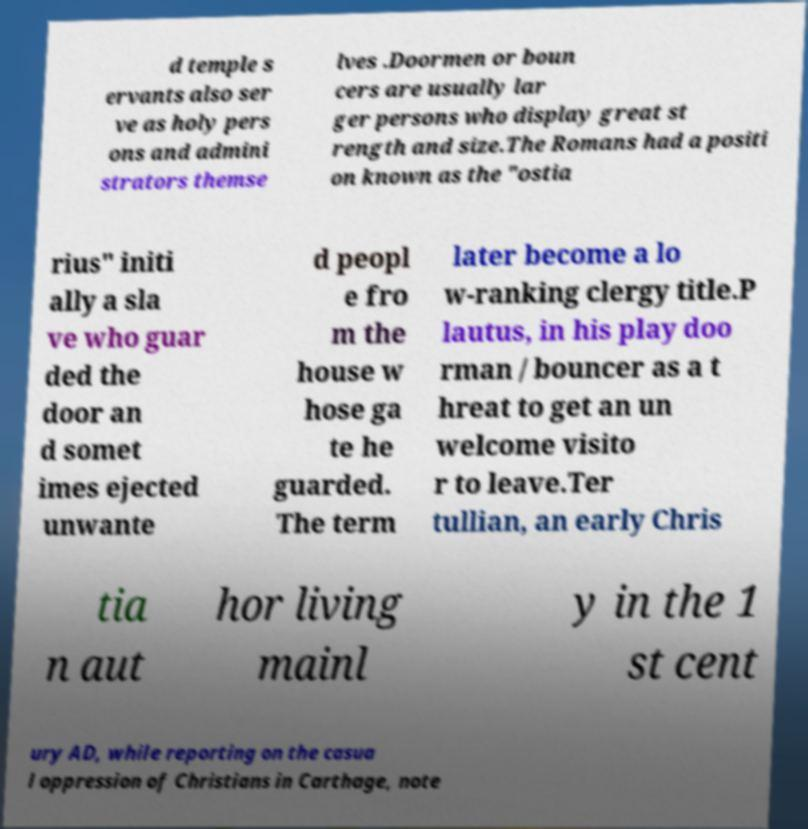There's text embedded in this image that I need extracted. Can you transcribe it verbatim? d temple s ervants also ser ve as holy pers ons and admini strators themse lves .Doormen or boun cers are usually lar ger persons who display great st rength and size.The Romans had a positi on known as the "ostia rius" initi ally a sla ve who guar ded the door an d somet imes ejected unwante d peopl e fro m the house w hose ga te he guarded. The term later become a lo w-ranking clergy title.P lautus, in his play doo rman / bouncer as a t hreat to get an un welcome visito r to leave.Ter tullian, an early Chris tia n aut hor living mainl y in the 1 st cent ury AD, while reporting on the casua l oppression of Christians in Carthage, note 